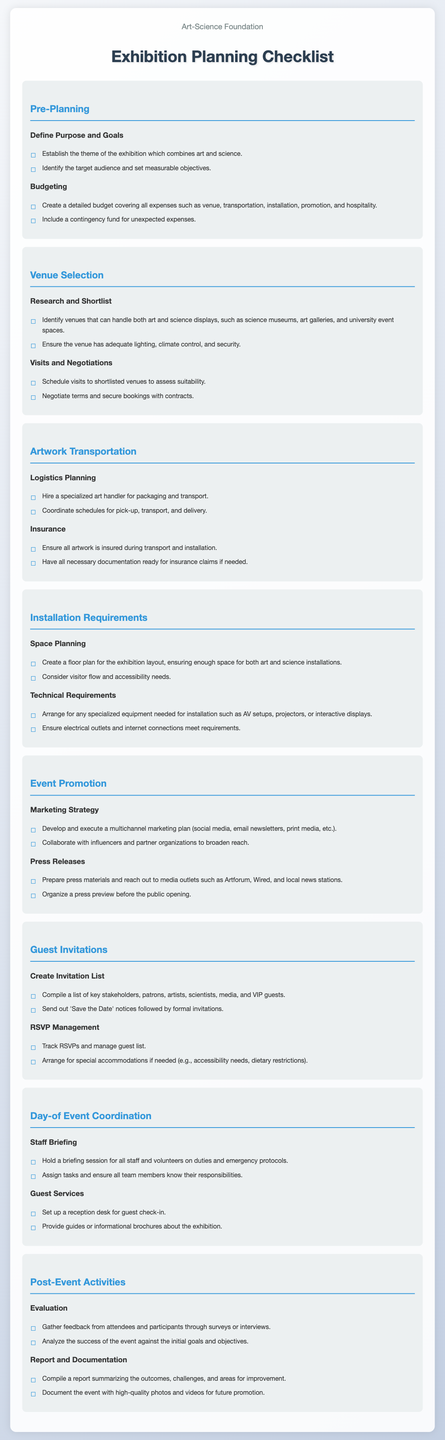What is the theme of the exhibition? The theme of the exhibition is established by identifying how art and science intersect.
Answer: Art and science What should be included in the budget? The budget should cover expenses such as venue, transportation, installation, promotion, and hospitality.
Answer: All expenses What type of venues should be considered? Venues that can handle art and science displays include science museums, art galleries, and university event spaces.
Answer: Science museums, art galleries, university event spaces What is essential for artwork transportation? It is essential to hire a specialized art handler for packaging and transport.
Answer: Specialized art handler What should be prepared for press materials? Press materials should be prepared for media outlets such as Artforum, Wired, and local news stations.
Answer: Media outlets What needs to be tracked for guest invitations? RSVPs need to be tracked and managed.
Answer: RSVPs What is the purpose of the staff briefing? The staff briefing is to inform all team members about their duties and emergency protocols.
Answer: Duties and emergency protocols What should be gathered post-event? Feedback from attendees and participants should be gathered.
Answer: Feedback 